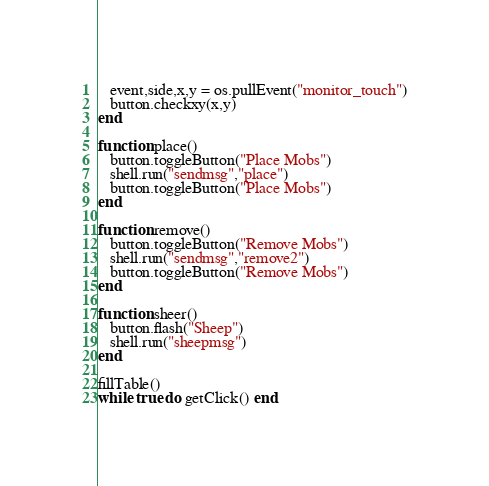Convert code to text. <code><loc_0><loc_0><loc_500><loc_500><_Lua_>   event,side,x,y = os.pullEvent("monitor_touch")
   button.checkxy(x,y)
end

function place()
   button.toggleButton("Place Mobs")
   shell.run("sendmsg","place")
   button.toggleButton("Place Mobs")
end

function remove()
   button.toggleButton("Remove Mobs")
   shell.run("sendmsg","remove2")
   button.toggleButton("Remove Mobs")
end

function sheer()
   button.flash("Sheep")
   shell.run("sheepmsg")
end

fillTable()
while true do getClick() end</code> 